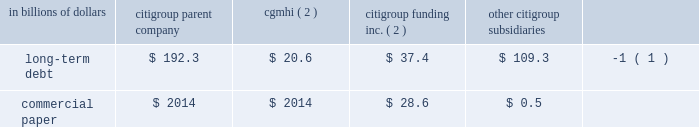Sources of liquidity primary sources of liquidity for citigroup and its principal subsidiaries include : 2022 deposits ; 2022 collateralized financing transactions ; 2022 senior and subordinated debt ; 2022 commercial paper ; 2022 trust preferred and preferred securities ; and 2022 purchased/wholesale funds .
Citigroup 2019s funding sources are diversified across funding types and geography , a benefit of its global franchise .
Funding for citigroup and its major operating subsidiaries includes a geographically diverse retail and corporate deposit base of $ 774.2 billion .
These deposits are diversified across products and regions , with approximately two-thirds of them outside of the u.s .
This diversification provides the company with an important , stable and low-cost source of funding .
A significant portion of these deposits has been , and is expected to be , long-term and stable , and are considered to be core .
There are qualitative as well as quantitative assessments that determine the company 2019s calculation of core deposits .
The first step in this process is a qualitative assessment of the deposits .
For example , as a result of the company 2019s qualitative analysis certain deposits with wholesale funding characteristics are excluded from consideration as core .
Deposits that qualify under the company 2019s qualitative assessments are then subjected to quantitative analysis .
Excluding the impact of changes in foreign exchange rates and the sale of our retail banking operations in germany during the year ending december 31 , 2008 , the company 2019s deposit base remained stable .
On a volume basis , deposit increases were noted in transaction services , u.s .
Retail banking and smith barney .
This was partially offset by the company 2019s decision to reduce deposits considered wholesale funding , consistent with the company 2019s de-leveraging efforts , and declines in international consumer banking and the private bank .
Citigroup and its subsidiaries have historically had a significant presence in the global capital markets .
The company 2019s capital markets funding activities have been primarily undertaken by two legal entities : ( i ) citigroup inc. , which issues long-term debt , medium-term notes , trust preferred securities , and preferred and common stock ; and ( ii ) citigroup funding inc .
( cfi ) , a first-tier subsidiary of citigroup , which issues commercial paper , medium-term notes and structured equity-linked and credit-linked notes , all of which are guaranteed by citigroup .
Other significant elements of long- term debt on the consolidated balance sheet include collateralized advances from the federal home loan bank system , long-term debt related to the consolidation of icg 2019s structured investment vehicles , asset-backed outstandings , and certain borrowings of foreign subsidiaries .
Each of citigroup 2019s major operating subsidiaries finances its operations on a basis consistent with its capitalization , regulatory structure and the environment in which it operates .
Particular attention is paid to those businesses that for tax , sovereign risk , or regulatory reasons cannot be freely and readily funded in the international markets .
Citigroup 2019s borrowings have historically been diversified by geography , investor , instrument and currency .
Decisions regarding the ultimate currency and interest rate profile of liquidity generated through these borrowings can be separated from the actual issuance through the use of derivative instruments .
Citigroup is a provider of liquidity facilities to the commercial paper programs of the two primary credit card securitization trusts with which it transacts .
Citigroup may also provide other types of support to the trusts .
As a result of the recent economic downturn , its impact on the cashflows of the trusts , and in response to credit rating agency reviews of the trusts , the company increased the credit enhancement in the omni trust , and plans to provide additional enhancement to the master trust ( see note 23 to consolidated financial statements on page 175 for a further discussion ) .
This support preserves investor sponsorship of our card securitization franchise , an important source of liquidity .
Banking subsidiaries there are various legal limitations on the ability of citigroup 2019s subsidiary depository institutions to extend credit , pay dividends or otherwise supply funds to citigroup and its non-bank subsidiaries .
The approval of the office of the comptroller of the currency , in the case of national banks , or the office of thrift supervision , in the case of federal savings banks , is required if total dividends declared in any calendar year exceed amounts specified by the applicable agency 2019s regulations .
State-chartered depository institutions are subject to dividend limitations imposed by applicable state law .
In determining the declaration of dividends , each depository institution must also consider its effect on applicable risk-based capital and leverage ratio requirements , as well as policy statements of the federal regulatory agencies that indicate that banking organizations should generally pay dividends out of current operating earnings .
Non-banking subsidiaries citigroup also receives dividends from its non-bank subsidiaries .
These non-bank subsidiaries are generally not subject to regulatory restrictions on dividends .
However , as discussed in 201ccapital resources and liquidity 201d on page 94 , the ability of cgmhi to declare dividends can be restricted by capital considerations of its broker-dealer subsidiaries .
Cgmhi 2019s consolidated balance sheet is liquid , with the vast majority of its assets consisting of marketable securities and collateralized short-term financing agreements arising from securities transactions .
Cgmhi monitors and evaluates the adequacy of its capital and borrowing base on a daily basis to maintain liquidity and to ensure that its capital base supports the regulatory capital requirements of its subsidiaries .
Some of citigroup 2019s non-bank subsidiaries , including cgmhi , have credit facilities with citigroup 2019s subsidiary depository institutions , including citibank , n.a .
Borrowings under these facilities must be secured in accordance with section 23a of the federal reserve act .
There are various legal restrictions on the extent to which a bank holding company and certain of its non-bank subsidiaries can borrow or obtain credit from citigroup 2019s subsidiary depository institutions or engage in certain other transactions with them .
In general , these restrictions require that transactions be on arm 2019s length terms and be secured by designated amounts of specified collateral .
See note 20 to the consolidated financial statements on page 169 .
At december 31 , 2008 , long-term debt and commercial paper outstanding for citigroup , cgmhi , cfi and citigroup 2019s subsidiaries were as follows : in billions of dollars citigroup parent company cgmhi ( 2 ) citigroup funding inc .
( 2 ) citigroup subsidiaries long-term debt $ 192.3 $ 20.6 $ 37.4 $ 109.3 ( 1 ) .
( 1 ) at december 31 , 2008 , approximately $ 67.4 billion relates to collateralized advances from the federal home loan bank .
( 2 ) citigroup inc .
Guarantees all of cfi 2019s debt and cgmhi 2019s publicly issued securities. .
What was the total long-term debt for citigroup subsidiaries long-term debt at december 312008? 
Computations: (109.3 + ((192.3 + 20.6) + 37.4))
Answer: 359.6. 